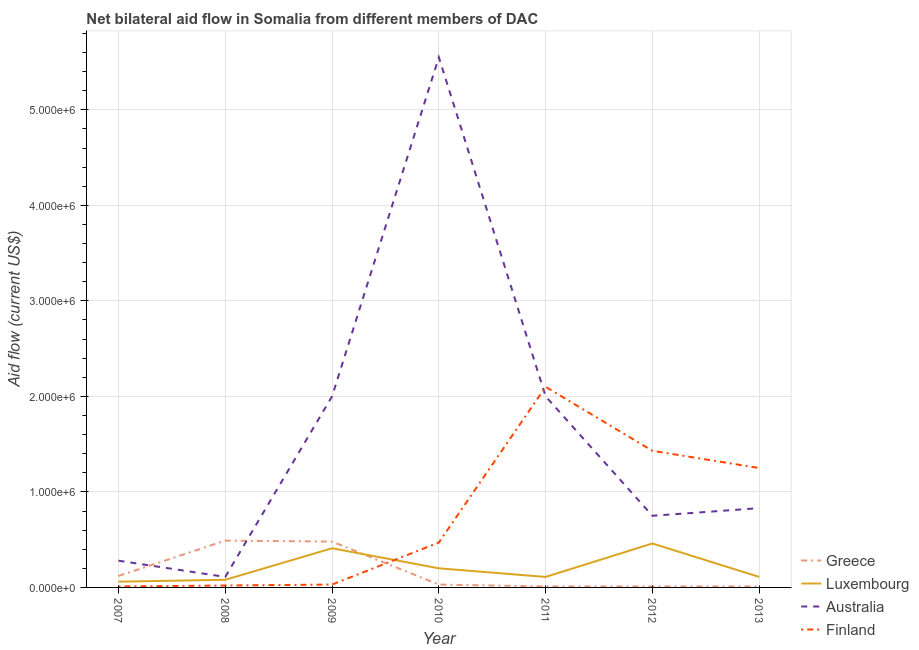How many different coloured lines are there?
Provide a succinct answer. 4. Does the line corresponding to amount of aid given by luxembourg intersect with the line corresponding to amount of aid given by greece?
Your answer should be compact. Yes. What is the amount of aid given by finland in 2012?
Provide a succinct answer. 1.43e+06. Across all years, what is the maximum amount of aid given by finland?
Make the answer very short. 2.10e+06. Across all years, what is the minimum amount of aid given by australia?
Offer a terse response. 1.10e+05. In which year was the amount of aid given by australia maximum?
Make the answer very short. 2010. In which year was the amount of aid given by finland minimum?
Provide a short and direct response. 2007. What is the total amount of aid given by australia in the graph?
Keep it short and to the point. 1.15e+07. What is the difference between the amount of aid given by finland in 2011 and that in 2013?
Give a very brief answer. 8.50e+05. What is the difference between the amount of aid given by greece in 2007 and the amount of aid given by luxembourg in 2013?
Your response must be concise. 10000. What is the average amount of aid given by finland per year?
Your response must be concise. 7.59e+05. In the year 2010, what is the difference between the amount of aid given by australia and amount of aid given by luxembourg?
Your answer should be compact. 5.35e+06. In how many years, is the amount of aid given by finland greater than 400000 US$?
Make the answer very short. 4. Is the amount of aid given by greece in 2011 less than that in 2012?
Your answer should be very brief. No. Is the difference between the amount of aid given by luxembourg in 2011 and 2013 greater than the difference between the amount of aid given by greece in 2011 and 2013?
Make the answer very short. No. What is the difference between the highest and the lowest amount of aid given by greece?
Offer a terse response. 4.80e+05. Is the amount of aid given by finland strictly greater than the amount of aid given by greece over the years?
Offer a very short reply. No. Is the amount of aid given by finland strictly less than the amount of aid given by greece over the years?
Keep it short and to the point. No. How many years are there in the graph?
Your response must be concise. 7. What is the difference between two consecutive major ticks on the Y-axis?
Offer a very short reply. 1.00e+06. Are the values on the major ticks of Y-axis written in scientific E-notation?
Provide a short and direct response. Yes. Does the graph contain any zero values?
Provide a short and direct response. No. Where does the legend appear in the graph?
Keep it short and to the point. Bottom right. What is the title of the graph?
Your answer should be very brief. Net bilateral aid flow in Somalia from different members of DAC. Does "Second 20% of population" appear as one of the legend labels in the graph?
Offer a very short reply. No. What is the label or title of the X-axis?
Your response must be concise. Year. What is the label or title of the Y-axis?
Offer a terse response. Aid flow (current US$). What is the Aid flow (current US$) of Luxembourg in 2007?
Provide a short and direct response. 6.00e+04. What is the Aid flow (current US$) of Luxembourg in 2008?
Offer a terse response. 8.00e+04. What is the Aid flow (current US$) in Luxembourg in 2009?
Ensure brevity in your answer.  4.10e+05. What is the Aid flow (current US$) of Australia in 2009?
Provide a short and direct response. 2.00e+06. What is the Aid flow (current US$) in Australia in 2010?
Your answer should be very brief. 5.55e+06. What is the Aid flow (current US$) of Finland in 2010?
Offer a very short reply. 4.70e+05. What is the Aid flow (current US$) of Greece in 2011?
Your answer should be very brief. 10000. What is the Aid flow (current US$) in Finland in 2011?
Provide a short and direct response. 2.10e+06. What is the Aid flow (current US$) of Australia in 2012?
Offer a terse response. 7.50e+05. What is the Aid flow (current US$) in Finland in 2012?
Offer a very short reply. 1.43e+06. What is the Aid flow (current US$) in Luxembourg in 2013?
Your response must be concise. 1.10e+05. What is the Aid flow (current US$) in Australia in 2013?
Keep it short and to the point. 8.30e+05. What is the Aid flow (current US$) of Finland in 2013?
Provide a succinct answer. 1.25e+06. Across all years, what is the maximum Aid flow (current US$) of Australia?
Make the answer very short. 5.55e+06. Across all years, what is the maximum Aid flow (current US$) of Finland?
Your answer should be compact. 2.10e+06. Across all years, what is the minimum Aid flow (current US$) of Greece?
Offer a terse response. 10000. Across all years, what is the minimum Aid flow (current US$) of Luxembourg?
Provide a succinct answer. 6.00e+04. Across all years, what is the minimum Aid flow (current US$) in Australia?
Make the answer very short. 1.10e+05. Across all years, what is the minimum Aid flow (current US$) in Finland?
Offer a very short reply. 10000. What is the total Aid flow (current US$) in Greece in the graph?
Provide a short and direct response. 1.15e+06. What is the total Aid flow (current US$) of Luxembourg in the graph?
Keep it short and to the point. 1.43e+06. What is the total Aid flow (current US$) of Australia in the graph?
Give a very brief answer. 1.15e+07. What is the total Aid flow (current US$) in Finland in the graph?
Provide a succinct answer. 5.31e+06. What is the difference between the Aid flow (current US$) in Greece in 2007 and that in 2008?
Offer a terse response. -3.70e+05. What is the difference between the Aid flow (current US$) of Luxembourg in 2007 and that in 2008?
Your answer should be compact. -2.00e+04. What is the difference between the Aid flow (current US$) of Finland in 2007 and that in 2008?
Your response must be concise. -10000. What is the difference between the Aid flow (current US$) of Greece in 2007 and that in 2009?
Your answer should be compact. -3.60e+05. What is the difference between the Aid flow (current US$) in Luxembourg in 2007 and that in 2009?
Provide a short and direct response. -3.50e+05. What is the difference between the Aid flow (current US$) in Australia in 2007 and that in 2009?
Offer a terse response. -1.72e+06. What is the difference between the Aid flow (current US$) in Finland in 2007 and that in 2009?
Provide a succinct answer. -2.00e+04. What is the difference between the Aid flow (current US$) of Australia in 2007 and that in 2010?
Provide a short and direct response. -5.27e+06. What is the difference between the Aid flow (current US$) in Finland in 2007 and that in 2010?
Keep it short and to the point. -4.60e+05. What is the difference between the Aid flow (current US$) of Greece in 2007 and that in 2011?
Your answer should be very brief. 1.10e+05. What is the difference between the Aid flow (current US$) in Luxembourg in 2007 and that in 2011?
Make the answer very short. -5.00e+04. What is the difference between the Aid flow (current US$) of Australia in 2007 and that in 2011?
Your answer should be very brief. -1.72e+06. What is the difference between the Aid flow (current US$) in Finland in 2007 and that in 2011?
Your response must be concise. -2.09e+06. What is the difference between the Aid flow (current US$) in Luxembourg in 2007 and that in 2012?
Provide a short and direct response. -4.00e+05. What is the difference between the Aid flow (current US$) in Australia in 2007 and that in 2012?
Provide a succinct answer. -4.70e+05. What is the difference between the Aid flow (current US$) in Finland in 2007 and that in 2012?
Offer a terse response. -1.42e+06. What is the difference between the Aid flow (current US$) in Greece in 2007 and that in 2013?
Your answer should be very brief. 1.10e+05. What is the difference between the Aid flow (current US$) of Australia in 2007 and that in 2013?
Your response must be concise. -5.50e+05. What is the difference between the Aid flow (current US$) in Finland in 2007 and that in 2013?
Keep it short and to the point. -1.24e+06. What is the difference between the Aid flow (current US$) in Greece in 2008 and that in 2009?
Keep it short and to the point. 10000. What is the difference between the Aid flow (current US$) of Luxembourg in 2008 and that in 2009?
Offer a terse response. -3.30e+05. What is the difference between the Aid flow (current US$) in Australia in 2008 and that in 2009?
Keep it short and to the point. -1.89e+06. What is the difference between the Aid flow (current US$) of Luxembourg in 2008 and that in 2010?
Your answer should be compact. -1.20e+05. What is the difference between the Aid flow (current US$) of Australia in 2008 and that in 2010?
Your response must be concise. -5.44e+06. What is the difference between the Aid flow (current US$) of Finland in 2008 and that in 2010?
Make the answer very short. -4.50e+05. What is the difference between the Aid flow (current US$) in Greece in 2008 and that in 2011?
Keep it short and to the point. 4.80e+05. What is the difference between the Aid flow (current US$) in Australia in 2008 and that in 2011?
Give a very brief answer. -1.89e+06. What is the difference between the Aid flow (current US$) of Finland in 2008 and that in 2011?
Give a very brief answer. -2.08e+06. What is the difference between the Aid flow (current US$) in Luxembourg in 2008 and that in 2012?
Your answer should be compact. -3.80e+05. What is the difference between the Aid flow (current US$) in Australia in 2008 and that in 2012?
Make the answer very short. -6.40e+05. What is the difference between the Aid flow (current US$) of Finland in 2008 and that in 2012?
Your answer should be very brief. -1.41e+06. What is the difference between the Aid flow (current US$) in Luxembourg in 2008 and that in 2013?
Provide a succinct answer. -3.00e+04. What is the difference between the Aid flow (current US$) of Australia in 2008 and that in 2013?
Your response must be concise. -7.20e+05. What is the difference between the Aid flow (current US$) of Finland in 2008 and that in 2013?
Your answer should be compact. -1.23e+06. What is the difference between the Aid flow (current US$) of Australia in 2009 and that in 2010?
Provide a succinct answer. -3.55e+06. What is the difference between the Aid flow (current US$) in Finland in 2009 and that in 2010?
Ensure brevity in your answer.  -4.40e+05. What is the difference between the Aid flow (current US$) in Greece in 2009 and that in 2011?
Your answer should be very brief. 4.70e+05. What is the difference between the Aid flow (current US$) in Luxembourg in 2009 and that in 2011?
Ensure brevity in your answer.  3.00e+05. What is the difference between the Aid flow (current US$) of Australia in 2009 and that in 2011?
Ensure brevity in your answer.  0. What is the difference between the Aid flow (current US$) of Finland in 2009 and that in 2011?
Make the answer very short. -2.07e+06. What is the difference between the Aid flow (current US$) of Australia in 2009 and that in 2012?
Offer a very short reply. 1.25e+06. What is the difference between the Aid flow (current US$) of Finland in 2009 and that in 2012?
Offer a very short reply. -1.40e+06. What is the difference between the Aid flow (current US$) in Greece in 2009 and that in 2013?
Your response must be concise. 4.70e+05. What is the difference between the Aid flow (current US$) in Australia in 2009 and that in 2013?
Give a very brief answer. 1.17e+06. What is the difference between the Aid flow (current US$) of Finland in 2009 and that in 2013?
Make the answer very short. -1.22e+06. What is the difference between the Aid flow (current US$) in Greece in 2010 and that in 2011?
Your answer should be compact. 2.00e+04. What is the difference between the Aid flow (current US$) in Luxembourg in 2010 and that in 2011?
Ensure brevity in your answer.  9.00e+04. What is the difference between the Aid flow (current US$) in Australia in 2010 and that in 2011?
Give a very brief answer. 3.55e+06. What is the difference between the Aid flow (current US$) of Finland in 2010 and that in 2011?
Offer a terse response. -1.63e+06. What is the difference between the Aid flow (current US$) in Greece in 2010 and that in 2012?
Provide a succinct answer. 2.00e+04. What is the difference between the Aid flow (current US$) of Australia in 2010 and that in 2012?
Your answer should be very brief. 4.80e+06. What is the difference between the Aid flow (current US$) of Finland in 2010 and that in 2012?
Ensure brevity in your answer.  -9.60e+05. What is the difference between the Aid flow (current US$) in Greece in 2010 and that in 2013?
Provide a short and direct response. 2.00e+04. What is the difference between the Aid flow (current US$) of Australia in 2010 and that in 2013?
Make the answer very short. 4.72e+06. What is the difference between the Aid flow (current US$) of Finland in 2010 and that in 2013?
Keep it short and to the point. -7.80e+05. What is the difference between the Aid flow (current US$) of Luxembourg in 2011 and that in 2012?
Provide a succinct answer. -3.50e+05. What is the difference between the Aid flow (current US$) in Australia in 2011 and that in 2012?
Offer a very short reply. 1.25e+06. What is the difference between the Aid flow (current US$) of Finland in 2011 and that in 2012?
Make the answer very short. 6.70e+05. What is the difference between the Aid flow (current US$) of Greece in 2011 and that in 2013?
Your answer should be compact. 0. What is the difference between the Aid flow (current US$) of Luxembourg in 2011 and that in 2013?
Offer a terse response. 0. What is the difference between the Aid flow (current US$) in Australia in 2011 and that in 2013?
Offer a terse response. 1.17e+06. What is the difference between the Aid flow (current US$) in Finland in 2011 and that in 2013?
Provide a succinct answer. 8.50e+05. What is the difference between the Aid flow (current US$) of Greece in 2012 and that in 2013?
Offer a terse response. 0. What is the difference between the Aid flow (current US$) in Luxembourg in 2012 and that in 2013?
Your answer should be very brief. 3.50e+05. What is the difference between the Aid flow (current US$) of Finland in 2012 and that in 2013?
Give a very brief answer. 1.80e+05. What is the difference between the Aid flow (current US$) in Greece in 2007 and the Aid flow (current US$) in Luxembourg in 2008?
Keep it short and to the point. 4.00e+04. What is the difference between the Aid flow (current US$) of Greece in 2007 and the Aid flow (current US$) of Australia in 2008?
Provide a succinct answer. 10000. What is the difference between the Aid flow (current US$) in Australia in 2007 and the Aid flow (current US$) in Finland in 2008?
Keep it short and to the point. 2.60e+05. What is the difference between the Aid flow (current US$) in Greece in 2007 and the Aid flow (current US$) in Australia in 2009?
Make the answer very short. -1.88e+06. What is the difference between the Aid flow (current US$) in Greece in 2007 and the Aid flow (current US$) in Finland in 2009?
Ensure brevity in your answer.  9.00e+04. What is the difference between the Aid flow (current US$) in Luxembourg in 2007 and the Aid flow (current US$) in Australia in 2009?
Provide a short and direct response. -1.94e+06. What is the difference between the Aid flow (current US$) in Luxembourg in 2007 and the Aid flow (current US$) in Finland in 2009?
Offer a terse response. 3.00e+04. What is the difference between the Aid flow (current US$) of Greece in 2007 and the Aid flow (current US$) of Luxembourg in 2010?
Offer a very short reply. -8.00e+04. What is the difference between the Aid flow (current US$) in Greece in 2007 and the Aid flow (current US$) in Australia in 2010?
Your answer should be compact. -5.43e+06. What is the difference between the Aid flow (current US$) of Greece in 2007 and the Aid flow (current US$) of Finland in 2010?
Make the answer very short. -3.50e+05. What is the difference between the Aid flow (current US$) of Luxembourg in 2007 and the Aid flow (current US$) of Australia in 2010?
Give a very brief answer. -5.49e+06. What is the difference between the Aid flow (current US$) in Luxembourg in 2007 and the Aid flow (current US$) in Finland in 2010?
Make the answer very short. -4.10e+05. What is the difference between the Aid flow (current US$) in Greece in 2007 and the Aid flow (current US$) in Australia in 2011?
Your answer should be very brief. -1.88e+06. What is the difference between the Aid flow (current US$) in Greece in 2007 and the Aid flow (current US$) in Finland in 2011?
Make the answer very short. -1.98e+06. What is the difference between the Aid flow (current US$) of Luxembourg in 2007 and the Aid flow (current US$) of Australia in 2011?
Provide a succinct answer. -1.94e+06. What is the difference between the Aid flow (current US$) in Luxembourg in 2007 and the Aid flow (current US$) in Finland in 2011?
Provide a short and direct response. -2.04e+06. What is the difference between the Aid flow (current US$) in Australia in 2007 and the Aid flow (current US$) in Finland in 2011?
Offer a terse response. -1.82e+06. What is the difference between the Aid flow (current US$) in Greece in 2007 and the Aid flow (current US$) in Australia in 2012?
Provide a succinct answer. -6.30e+05. What is the difference between the Aid flow (current US$) in Greece in 2007 and the Aid flow (current US$) in Finland in 2012?
Ensure brevity in your answer.  -1.31e+06. What is the difference between the Aid flow (current US$) of Luxembourg in 2007 and the Aid flow (current US$) of Australia in 2012?
Make the answer very short. -6.90e+05. What is the difference between the Aid flow (current US$) in Luxembourg in 2007 and the Aid flow (current US$) in Finland in 2012?
Make the answer very short. -1.37e+06. What is the difference between the Aid flow (current US$) of Australia in 2007 and the Aid flow (current US$) of Finland in 2012?
Offer a very short reply. -1.15e+06. What is the difference between the Aid flow (current US$) of Greece in 2007 and the Aid flow (current US$) of Australia in 2013?
Make the answer very short. -7.10e+05. What is the difference between the Aid flow (current US$) of Greece in 2007 and the Aid flow (current US$) of Finland in 2013?
Ensure brevity in your answer.  -1.13e+06. What is the difference between the Aid flow (current US$) in Luxembourg in 2007 and the Aid flow (current US$) in Australia in 2013?
Keep it short and to the point. -7.70e+05. What is the difference between the Aid flow (current US$) in Luxembourg in 2007 and the Aid flow (current US$) in Finland in 2013?
Offer a very short reply. -1.19e+06. What is the difference between the Aid flow (current US$) of Australia in 2007 and the Aid flow (current US$) of Finland in 2013?
Offer a terse response. -9.70e+05. What is the difference between the Aid flow (current US$) in Greece in 2008 and the Aid flow (current US$) in Luxembourg in 2009?
Ensure brevity in your answer.  8.00e+04. What is the difference between the Aid flow (current US$) of Greece in 2008 and the Aid flow (current US$) of Australia in 2009?
Make the answer very short. -1.51e+06. What is the difference between the Aid flow (current US$) of Luxembourg in 2008 and the Aid flow (current US$) of Australia in 2009?
Provide a succinct answer. -1.92e+06. What is the difference between the Aid flow (current US$) of Greece in 2008 and the Aid flow (current US$) of Australia in 2010?
Offer a terse response. -5.06e+06. What is the difference between the Aid flow (current US$) in Luxembourg in 2008 and the Aid flow (current US$) in Australia in 2010?
Offer a very short reply. -5.47e+06. What is the difference between the Aid flow (current US$) of Luxembourg in 2008 and the Aid flow (current US$) of Finland in 2010?
Offer a very short reply. -3.90e+05. What is the difference between the Aid flow (current US$) in Australia in 2008 and the Aid flow (current US$) in Finland in 2010?
Offer a terse response. -3.60e+05. What is the difference between the Aid flow (current US$) of Greece in 2008 and the Aid flow (current US$) of Australia in 2011?
Your answer should be very brief. -1.51e+06. What is the difference between the Aid flow (current US$) in Greece in 2008 and the Aid flow (current US$) in Finland in 2011?
Keep it short and to the point. -1.61e+06. What is the difference between the Aid flow (current US$) of Luxembourg in 2008 and the Aid flow (current US$) of Australia in 2011?
Make the answer very short. -1.92e+06. What is the difference between the Aid flow (current US$) in Luxembourg in 2008 and the Aid flow (current US$) in Finland in 2011?
Offer a terse response. -2.02e+06. What is the difference between the Aid flow (current US$) in Australia in 2008 and the Aid flow (current US$) in Finland in 2011?
Provide a succinct answer. -1.99e+06. What is the difference between the Aid flow (current US$) of Greece in 2008 and the Aid flow (current US$) of Luxembourg in 2012?
Provide a succinct answer. 3.00e+04. What is the difference between the Aid flow (current US$) of Greece in 2008 and the Aid flow (current US$) of Australia in 2012?
Provide a succinct answer. -2.60e+05. What is the difference between the Aid flow (current US$) of Greece in 2008 and the Aid flow (current US$) of Finland in 2012?
Offer a terse response. -9.40e+05. What is the difference between the Aid flow (current US$) of Luxembourg in 2008 and the Aid flow (current US$) of Australia in 2012?
Offer a terse response. -6.70e+05. What is the difference between the Aid flow (current US$) of Luxembourg in 2008 and the Aid flow (current US$) of Finland in 2012?
Offer a very short reply. -1.35e+06. What is the difference between the Aid flow (current US$) of Australia in 2008 and the Aid flow (current US$) of Finland in 2012?
Your answer should be compact. -1.32e+06. What is the difference between the Aid flow (current US$) in Greece in 2008 and the Aid flow (current US$) in Australia in 2013?
Your answer should be compact. -3.40e+05. What is the difference between the Aid flow (current US$) of Greece in 2008 and the Aid flow (current US$) of Finland in 2013?
Your answer should be very brief. -7.60e+05. What is the difference between the Aid flow (current US$) of Luxembourg in 2008 and the Aid flow (current US$) of Australia in 2013?
Offer a very short reply. -7.50e+05. What is the difference between the Aid flow (current US$) in Luxembourg in 2008 and the Aid flow (current US$) in Finland in 2013?
Keep it short and to the point. -1.17e+06. What is the difference between the Aid flow (current US$) of Australia in 2008 and the Aid flow (current US$) of Finland in 2013?
Provide a short and direct response. -1.14e+06. What is the difference between the Aid flow (current US$) of Greece in 2009 and the Aid flow (current US$) of Luxembourg in 2010?
Your answer should be compact. 2.80e+05. What is the difference between the Aid flow (current US$) in Greece in 2009 and the Aid flow (current US$) in Australia in 2010?
Offer a very short reply. -5.07e+06. What is the difference between the Aid flow (current US$) of Luxembourg in 2009 and the Aid flow (current US$) of Australia in 2010?
Offer a very short reply. -5.14e+06. What is the difference between the Aid flow (current US$) of Australia in 2009 and the Aid flow (current US$) of Finland in 2010?
Provide a short and direct response. 1.53e+06. What is the difference between the Aid flow (current US$) in Greece in 2009 and the Aid flow (current US$) in Luxembourg in 2011?
Keep it short and to the point. 3.70e+05. What is the difference between the Aid flow (current US$) in Greece in 2009 and the Aid flow (current US$) in Australia in 2011?
Your answer should be very brief. -1.52e+06. What is the difference between the Aid flow (current US$) of Greece in 2009 and the Aid flow (current US$) of Finland in 2011?
Ensure brevity in your answer.  -1.62e+06. What is the difference between the Aid flow (current US$) in Luxembourg in 2009 and the Aid flow (current US$) in Australia in 2011?
Your response must be concise. -1.59e+06. What is the difference between the Aid flow (current US$) of Luxembourg in 2009 and the Aid flow (current US$) of Finland in 2011?
Your response must be concise. -1.69e+06. What is the difference between the Aid flow (current US$) of Greece in 2009 and the Aid flow (current US$) of Finland in 2012?
Provide a short and direct response. -9.50e+05. What is the difference between the Aid flow (current US$) of Luxembourg in 2009 and the Aid flow (current US$) of Australia in 2012?
Provide a short and direct response. -3.40e+05. What is the difference between the Aid flow (current US$) in Luxembourg in 2009 and the Aid flow (current US$) in Finland in 2012?
Your response must be concise. -1.02e+06. What is the difference between the Aid flow (current US$) of Australia in 2009 and the Aid flow (current US$) of Finland in 2012?
Your answer should be very brief. 5.70e+05. What is the difference between the Aid flow (current US$) in Greece in 2009 and the Aid flow (current US$) in Australia in 2013?
Give a very brief answer. -3.50e+05. What is the difference between the Aid flow (current US$) in Greece in 2009 and the Aid flow (current US$) in Finland in 2013?
Your answer should be very brief. -7.70e+05. What is the difference between the Aid flow (current US$) in Luxembourg in 2009 and the Aid flow (current US$) in Australia in 2013?
Your response must be concise. -4.20e+05. What is the difference between the Aid flow (current US$) in Luxembourg in 2009 and the Aid flow (current US$) in Finland in 2013?
Offer a terse response. -8.40e+05. What is the difference between the Aid flow (current US$) in Australia in 2009 and the Aid flow (current US$) in Finland in 2013?
Your response must be concise. 7.50e+05. What is the difference between the Aid flow (current US$) of Greece in 2010 and the Aid flow (current US$) of Luxembourg in 2011?
Your answer should be compact. -8.00e+04. What is the difference between the Aid flow (current US$) in Greece in 2010 and the Aid flow (current US$) in Australia in 2011?
Give a very brief answer. -1.97e+06. What is the difference between the Aid flow (current US$) in Greece in 2010 and the Aid flow (current US$) in Finland in 2011?
Your answer should be very brief. -2.07e+06. What is the difference between the Aid flow (current US$) of Luxembourg in 2010 and the Aid flow (current US$) of Australia in 2011?
Your answer should be compact. -1.80e+06. What is the difference between the Aid flow (current US$) in Luxembourg in 2010 and the Aid flow (current US$) in Finland in 2011?
Provide a succinct answer. -1.90e+06. What is the difference between the Aid flow (current US$) in Australia in 2010 and the Aid flow (current US$) in Finland in 2011?
Your answer should be very brief. 3.45e+06. What is the difference between the Aid flow (current US$) of Greece in 2010 and the Aid flow (current US$) of Luxembourg in 2012?
Your answer should be compact. -4.30e+05. What is the difference between the Aid flow (current US$) of Greece in 2010 and the Aid flow (current US$) of Australia in 2012?
Keep it short and to the point. -7.20e+05. What is the difference between the Aid flow (current US$) in Greece in 2010 and the Aid flow (current US$) in Finland in 2012?
Provide a succinct answer. -1.40e+06. What is the difference between the Aid flow (current US$) of Luxembourg in 2010 and the Aid flow (current US$) of Australia in 2012?
Give a very brief answer. -5.50e+05. What is the difference between the Aid flow (current US$) of Luxembourg in 2010 and the Aid flow (current US$) of Finland in 2012?
Provide a succinct answer. -1.23e+06. What is the difference between the Aid flow (current US$) of Australia in 2010 and the Aid flow (current US$) of Finland in 2012?
Make the answer very short. 4.12e+06. What is the difference between the Aid flow (current US$) of Greece in 2010 and the Aid flow (current US$) of Luxembourg in 2013?
Your answer should be compact. -8.00e+04. What is the difference between the Aid flow (current US$) of Greece in 2010 and the Aid flow (current US$) of Australia in 2013?
Make the answer very short. -8.00e+05. What is the difference between the Aid flow (current US$) in Greece in 2010 and the Aid flow (current US$) in Finland in 2013?
Offer a terse response. -1.22e+06. What is the difference between the Aid flow (current US$) in Luxembourg in 2010 and the Aid flow (current US$) in Australia in 2013?
Make the answer very short. -6.30e+05. What is the difference between the Aid flow (current US$) in Luxembourg in 2010 and the Aid flow (current US$) in Finland in 2013?
Offer a very short reply. -1.05e+06. What is the difference between the Aid flow (current US$) of Australia in 2010 and the Aid flow (current US$) of Finland in 2013?
Your response must be concise. 4.30e+06. What is the difference between the Aid flow (current US$) in Greece in 2011 and the Aid flow (current US$) in Luxembourg in 2012?
Provide a short and direct response. -4.50e+05. What is the difference between the Aid flow (current US$) of Greece in 2011 and the Aid flow (current US$) of Australia in 2012?
Offer a terse response. -7.40e+05. What is the difference between the Aid flow (current US$) in Greece in 2011 and the Aid flow (current US$) in Finland in 2012?
Offer a terse response. -1.42e+06. What is the difference between the Aid flow (current US$) of Luxembourg in 2011 and the Aid flow (current US$) of Australia in 2012?
Your answer should be compact. -6.40e+05. What is the difference between the Aid flow (current US$) of Luxembourg in 2011 and the Aid flow (current US$) of Finland in 2012?
Ensure brevity in your answer.  -1.32e+06. What is the difference between the Aid flow (current US$) of Australia in 2011 and the Aid flow (current US$) of Finland in 2012?
Provide a short and direct response. 5.70e+05. What is the difference between the Aid flow (current US$) in Greece in 2011 and the Aid flow (current US$) in Luxembourg in 2013?
Your answer should be very brief. -1.00e+05. What is the difference between the Aid flow (current US$) of Greece in 2011 and the Aid flow (current US$) of Australia in 2013?
Keep it short and to the point. -8.20e+05. What is the difference between the Aid flow (current US$) in Greece in 2011 and the Aid flow (current US$) in Finland in 2013?
Your answer should be very brief. -1.24e+06. What is the difference between the Aid flow (current US$) in Luxembourg in 2011 and the Aid flow (current US$) in Australia in 2013?
Provide a succinct answer. -7.20e+05. What is the difference between the Aid flow (current US$) of Luxembourg in 2011 and the Aid flow (current US$) of Finland in 2013?
Offer a terse response. -1.14e+06. What is the difference between the Aid flow (current US$) of Australia in 2011 and the Aid flow (current US$) of Finland in 2013?
Your answer should be compact. 7.50e+05. What is the difference between the Aid flow (current US$) of Greece in 2012 and the Aid flow (current US$) of Luxembourg in 2013?
Provide a short and direct response. -1.00e+05. What is the difference between the Aid flow (current US$) in Greece in 2012 and the Aid flow (current US$) in Australia in 2013?
Keep it short and to the point. -8.20e+05. What is the difference between the Aid flow (current US$) in Greece in 2012 and the Aid flow (current US$) in Finland in 2013?
Provide a succinct answer. -1.24e+06. What is the difference between the Aid flow (current US$) of Luxembourg in 2012 and the Aid flow (current US$) of Australia in 2013?
Keep it short and to the point. -3.70e+05. What is the difference between the Aid flow (current US$) of Luxembourg in 2012 and the Aid flow (current US$) of Finland in 2013?
Keep it short and to the point. -7.90e+05. What is the difference between the Aid flow (current US$) of Australia in 2012 and the Aid flow (current US$) of Finland in 2013?
Offer a very short reply. -5.00e+05. What is the average Aid flow (current US$) in Greece per year?
Give a very brief answer. 1.64e+05. What is the average Aid flow (current US$) in Luxembourg per year?
Your response must be concise. 2.04e+05. What is the average Aid flow (current US$) in Australia per year?
Provide a succinct answer. 1.65e+06. What is the average Aid flow (current US$) in Finland per year?
Provide a short and direct response. 7.59e+05. In the year 2007, what is the difference between the Aid flow (current US$) in Greece and Aid flow (current US$) in Australia?
Give a very brief answer. -1.60e+05. In the year 2007, what is the difference between the Aid flow (current US$) in Luxembourg and Aid flow (current US$) in Australia?
Your answer should be very brief. -2.20e+05. In the year 2007, what is the difference between the Aid flow (current US$) of Luxembourg and Aid flow (current US$) of Finland?
Keep it short and to the point. 5.00e+04. In the year 2007, what is the difference between the Aid flow (current US$) of Australia and Aid flow (current US$) of Finland?
Your response must be concise. 2.70e+05. In the year 2008, what is the difference between the Aid flow (current US$) in Greece and Aid flow (current US$) in Australia?
Your response must be concise. 3.80e+05. In the year 2008, what is the difference between the Aid flow (current US$) of Luxembourg and Aid flow (current US$) of Australia?
Keep it short and to the point. -3.00e+04. In the year 2008, what is the difference between the Aid flow (current US$) of Australia and Aid flow (current US$) of Finland?
Ensure brevity in your answer.  9.00e+04. In the year 2009, what is the difference between the Aid flow (current US$) of Greece and Aid flow (current US$) of Australia?
Your response must be concise. -1.52e+06. In the year 2009, what is the difference between the Aid flow (current US$) of Greece and Aid flow (current US$) of Finland?
Your answer should be compact. 4.50e+05. In the year 2009, what is the difference between the Aid flow (current US$) in Luxembourg and Aid flow (current US$) in Australia?
Your response must be concise. -1.59e+06. In the year 2009, what is the difference between the Aid flow (current US$) in Australia and Aid flow (current US$) in Finland?
Keep it short and to the point. 1.97e+06. In the year 2010, what is the difference between the Aid flow (current US$) in Greece and Aid flow (current US$) in Luxembourg?
Offer a terse response. -1.70e+05. In the year 2010, what is the difference between the Aid flow (current US$) in Greece and Aid flow (current US$) in Australia?
Your answer should be compact. -5.52e+06. In the year 2010, what is the difference between the Aid flow (current US$) of Greece and Aid flow (current US$) of Finland?
Your response must be concise. -4.40e+05. In the year 2010, what is the difference between the Aid flow (current US$) of Luxembourg and Aid flow (current US$) of Australia?
Provide a short and direct response. -5.35e+06. In the year 2010, what is the difference between the Aid flow (current US$) in Australia and Aid flow (current US$) in Finland?
Provide a short and direct response. 5.08e+06. In the year 2011, what is the difference between the Aid flow (current US$) in Greece and Aid flow (current US$) in Luxembourg?
Your answer should be compact. -1.00e+05. In the year 2011, what is the difference between the Aid flow (current US$) of Greece and Aid flow (current US$) of Australia?
Your answer should be compact. -1.99e+06. In the year 2011, what is the difference between the Aid flow (current US$) of Greece and Aid flow (current US$) of Finland?
Give a very brief answer. -2.09e+06. In the year 2011, what is the difference between the Aid flow (current US$) in Luxembourg and Aid flow (current US$) in Australia?
Ensure brevity in your answer.  -1.89e+06. In the year 2011, what is the difference between the Aid flow (current US$) in Luxembourg and Aid flow (current US$) in Finland?
Your response must be concise. -1.99e+06. In the year 2011, what is the difference between the Aid flow (current US$) in Australia and Aid flow (current US$) in Finland?
Your response must be concise. -1.00e+05. In the year 2012, what is the difference between the Aid flow (current US$) of Greece and Aid flow (current US$) of Luxembourg?
Your answer should be very brief. -4.50e+05. In the year 2012, what is the difference between the Aid flow (current US$) in Greece and Aid flow (current US$) in Australia?
Ensure brevity in your answer.  -7.40e+05. In the year 2012, what is the difference between the Aid flow (current US$) of Greece and Aid flow (current US$) of Finland?
Your answer should be very brief. -1.42e+06. In the year 2012, what is the difference between the Aid flow (current US$) of Luxembourg and Aid flow (current US$) of Finland?
Provide a short and direct response. -9.70e+05. In the year 2012, what is the difference between the Aid flow (current US$) in Australia and Aid flow (current US$) in Finland?
Offer a terse response. -6.80e+05. In the year 2013, what is the difference between the Aid flow (current US$) in Greece and Aid flow (current US$) in Luxembourg?
Make the answer very short. -1.00e+05. In the year 2013, what is the difference between the Aid flow (current US$) in Greece and Aid flow (current US$) in Australia?
Offer a very short reply. -8.20e+05. In the year 2013, what is the difference between the Aid flow (current US$) in Greece and Aid flow (current US$) in Finland?
Keep it short and to the point. -1.24e+06. In the year 2013, what is the difference between the Aid flow (current US$) of Luxembourg and Aid flow (current US$) of Australia?
Your response must be concise. -7.20e+05. In the year 2013, what is the difference between the Aid flow (current US$) of Luxembourg and Aid flow (current US$) of Finland?
Your response must be concise. -1.14e+06. In the year 2013, what is the difference between the Aid flow (current US$) in Australia and Aid flow (current US$) in Finland?
Keep it short and to the point. -4.20e+05. What is the ratio of the Aid flow (current US$) of Greece in 2007 to that in 2008?
Ensure brevity in your answer.  0.24. What is the ratio of the Aid flow (current US$) of Luxembourg in 2007 to that in 2008?
Your response must be concise. 0.75. What is the ratio of the Aid flow (current US$) of Australia in 2007 to that in 2008?
Provide a short and direct response. 2.55. What is the ratio of the Aid flow (current US$) in Greece in 2007 to that in 2009?
Offer a terse response. 0.25. What is the ratio of the Aid flow (current US$) of Luxembourg in 2007 to that in 2009?
Ensure brevity in your answer.  0.15. What is the ratio of the Aid flow (current US$) of Australia in 2007 to that in 2009?
Provide a short and direct response. 0.14. What is the ratio of the Aid flow (current US$) of Luxembourg in 2007 to that in 2010?
Ensure brevity in your answer.  0.3. What is the ratio of the Aid flow (current US$) of Australia in 2007 to that in 2010?
Keep it short and to the point. 0.05. What is the ratio of the Aid flow (current US$) in Finland in 2007 to that in 2010?
Provide a short and direct response. 0.02. What is the ratio of the Aid flow (current US$) of Luxembourg in 2007 to that in 2011?
Ensure brevity in your answer.  0.55. What is the ratio of the Aid flow (current US$) in Australia in 2007 to that in 2011?
Provide a short and direct response. 0.14. What is the ratio of the Aid flow (current US$) of Finland in 2007 to that in 2011?
Provide a short and direct response. 0. What is the ratio of the Aid flow (current US$) of Greece in 2007 to that in 2012?
Ensure brevity in your answer.  12. What is the ratio of the Aid flow (current US$) of Luxembourg in 2007 to that in 2012?
Your answer should be compact. 0.13. What is the ratio of the Aid flow (current US$) in Australia in 2007 to that in 2012?
Provide a succinct answer. 0.37. What is the ratio of the Aid flow (current US$) of Finland in 2007 to that in 2012?
Offer a terse response. 0.01. What is the ratio of the Aid flow (current US$) in Luxembourg in 2007 to that in 2013?
Your answer should be very brief. 0.55. What is the ratio of the Aid flow (current US$) in Australia in 2007 to that in 2013?
Provide a short and direct response. 0.34. What is the ratio of the Aid flow (current US$) in Finland in 2007 to that in 2013?
Provide a short and direct response. 0.01. What is the ratio of the Aid flow (current US$) in Greece in 2008 to that in 2009?
Ensure brevity in your answer.  1.02. What is the ratio of the Aid flow (current US$) in Luxembourg in 2008 to that in 2009?
Provide a succinct answer. 0.2. What is the ratio of the Aid flow (current US$) of Australia in 2008 to that in 2009?
Your answer should be very brief. 0.06. What is the ratio of the Aid flow (current US$) in Finland in 2008 to that in 2009?
Make the answer very short. 0.67. What is the ratio of the Aid flow (current US$) in Greece in 2008 to that in 2010?
Provide a succinct answer. 16.33. What is the ratio of the Aid flow (current US$) in Luxembourg in 2008 to that in 2010?
Your response must be concise. 0.4. What is the ratio of the Aid flow (current US$) in Australia in 2008 to that in 2010?
Give a very brief answer. 0.02. What is the ratio of the Aid flow (current US$) of Finland in 2008 to that in 2010?
Your answer should be compact. 0.04. What is the ratio of the Aid flow (current US$) of Luxembourg in 2008 to that in 2011?
Your answer should be compact. 0.73. What is the ratio of the Aid flow (current US$) in Australia in 2008 to that in 2011?
Provide a succinct answer. 0.06. What is the ratio of the Aid flow (current US$) in Finland in 2008 to that in 2011?
Your answer should be compact. 0.01. What is the ratio of the Aid flow (current US$) of Greece in 2008 to that in 2012?
Provide a short and direct response. 49. What is the ratio of the Aid flow (current US$) in Luxembourg in 2008 to that in 2012?
Keep it short and to the point. 0.17. What is the ratio of the Aid flow (current US$) of Australia in 2008 to that in 2012?
Your answer should be very brief. 0.15. What is the ratio of the Aid flow (current US$) in Finland in 2008 to that in 2012?
Make the answer very short. 0.01. What is the ratio of the Aid flow (current US$) of Greece in 2008 to that in 2013?
Keep it short and to the point. 49. What is the ratio of the Aid flow (current US$) of Luxembourg in 2008 to that in 2013?
Provide a short and direct response. 0.73. What is the ratio of the Aid flow (current US$) in Australia in 2008 to that in 2013?
Your answer should be very brief. 0.13. What is the ratio of the Aid flow (current US$) in Finland in 2008 to that in 2013?
Provide a succinct answer. 0.02. What is the ratio of the Aid flow (current US$) of Luxembourg in 2009 to that in 2010?
Your answer should be compact. 2.05. What is the ratio of the Aid flow (current US$) of Australia in 2009 to that in 2010?
Give a very brief answer. 0.36. What is the ratio of the Aid flow (current US$) in Finland in 2009 to that in 2010?
Keep it short and to the point. 0.06. What is the ratio of the Aid flow (current US$) in Luxembourg in 2009 to that in 2011?
Offer a very short reply. 3.73. What is the ratio of the Aid flow (current US$) of Australia in 2009 to that in 2011?
Provide a short and direct response. 1. What is the ratio of the Aid flow (current US$) of Finland in 2009 to that in 2011?
Make the answer very short. 0.01. What is the ratio of the Aid flow (current US$) of Luxembourg in 2009 to that in 2012?
Ensure brevity in your answer.  0.89. What is the ratio of the Aid flow (current US$) in Australia in 2009 to that in 2012?
Give a very brief answer. 2.67. What is the ratio of the Aid flow (current US$) of Finland in 2009 to that in 2012?
Your answer should be compact. 0.02. What is the ratio of the Aid flow (current US$) in Luxembourg in 2009 to that in 2013?
Provide a succinct answer. 3.73. What is the ratio of the Aid flow (current US$) of Australia in 2009 to that in 2013?
Give a very brief answer. 2.41. What is the ratio of the Aid flow (current US$) in Finland in 2009 to that in 2013?
Provide a short and direct response. 0.02. What is the ratio of the Aid flow (current US$) of Luxembourg in 2010 to that in 2011?
Your answer should be very brief. 1.82. What is the ratio of the Aid flow (current US$) in Australia in 2010 to that in 2011?
Your response must be concise. 2.77. What is the ratio of the Aid flow (current US$) of Finland in 2010 to that in 2011?
Ensure brevity in your answer.  0.22. What is the ratio of the Aid flow (current US$) of Greece in 2010 to that in 2012?
Ensure brevity in your answer.  3. What is the ratio of the Aid flow (current US$) of Luxembourg in 2010 to that in 2012?
Give a very brief answer. 0.43. What is the ratio of the Aid flow (current US$) in Finland in 2010 to that in 2012?
Offer a terse response. 0.33. What is the ratio of the Aid flow (current US$) in Greece in 2010 to that in 2013?
Ensure brevity in your answer.  3. What is the ratio of the Aid flow (current US$) of Luxembourg in 2010 to that in 2013?
Ensure brevity in your answer.  1.82. What is the ratio of the Aid flow (current US$) of Australia in 2010 to that in 2013?
Your answer should be very brief. 6.69. What is the ratio of the Aid flow (current US$) of Finland in 2010 to that in 2013?
Your response must be concise. 0.38. What is the ratio of the Aid flow (current US$) of Luxembourg in 2011 to that in 2012?
Provide a succinct answer. 0.24. What is the ratio of the Aid flow (current US$) of Australia in 2011 to that in 2012?
Your response must be concise. 2.67. What is the ratio of the Aid flow (current US$) of Finland in 2011 to that in 2012?
Provide a short and direct response. 1.47. What is the ratio of the Aid flow (current US$) of Greece in 2011 to that in 2013?
Your answer should be compact. 1. What is the ratio of the Aid flow (current US$) of Luxembourg in 2011 to that in 2013?
Make the answer very short. 1. What is the ratio of the Aid flow (current US$) in Australia in 2011 to that in 2013?
Offer a very short reply. 2.41. What is the ratio of the Aid flow (current US$) in Finland in 2011 to that in 2013?
Provide a succinct answer. 1.68. What is the ratio of the Aid flow (current US$) of Greece in 2012 to that in 2013?
Your response must be concise. 1. What is the ratio of the Aid flow (current US$) of Luxembourg in 2012 to that in 2013?
Your answer should be very brief. 4.18. What is the ratio of the Aid flow (current US$) in Australia in 2012 to that in 2013?
Offer a terse response. 0.9. What is the ratio of the Aid flow (current US$) in Finland in 2012 to that in 2013?
Ensure brevity in your answer.  1.14. What is the difference between the highest and the second highest Aid flow (current US$) of Luxembourg?
Your answer should be very brief. 5.00e+04. What is the difference between the highest and the second highest Aid flow (current US$) of Australia?
Make the answer very short. 3.55e+06. What is the difference between the highest and the second highest Aid flow (current US$) in Finland?
Your answer should be very brief. 6.70e+05. What is the difference between the highest and the lowest Aid flow (current US$) in Luxembourg?
Your response must be concise. 4.00e+05. What is the difference between the highest and the lowest Aid flow (current US$) in Australia?
Provide a short and direct response. 5.44e+06. What is the difference between the highest and the lowest Aid flow (current US$) in Finland?
Your answer should be very brief. 2.09e+06. 